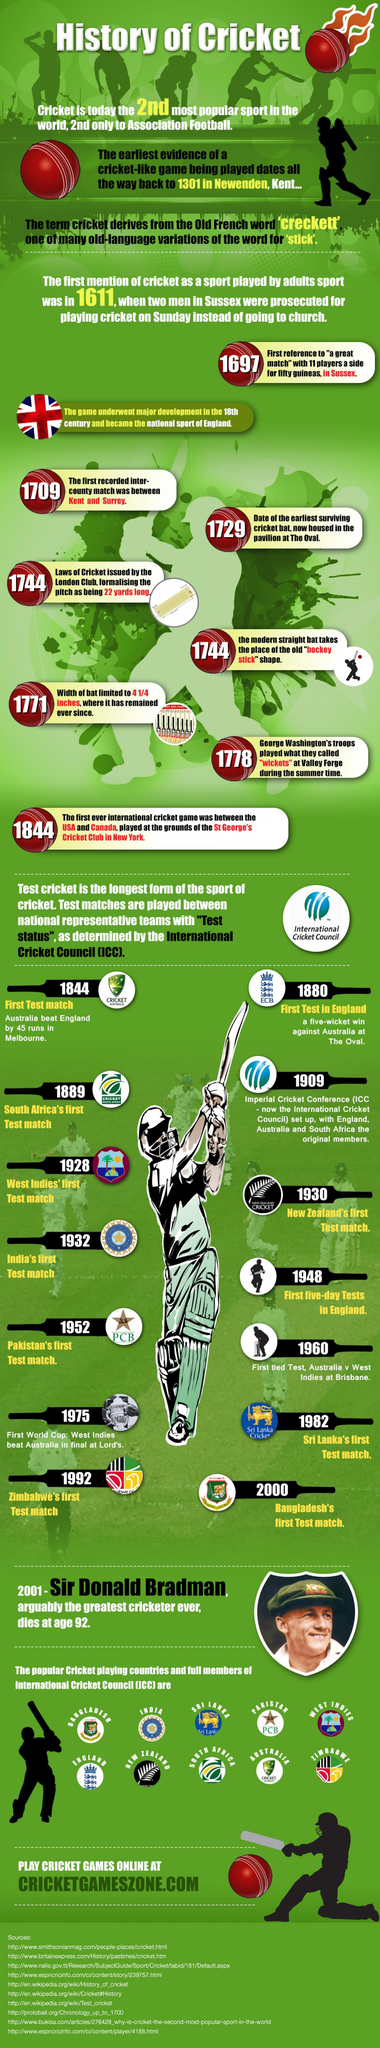Draw attention to some important aspects in this diagram. The country that played its first Test match last among the full members listed in the infographic is Bangladesh. The earliest teams in the International Cricket Council (ICC) were England, Australia, and South Africa, who were established in the late 19th and early 20th centuries. India played its first test match earlier than Sri Lanka or Pakistan. Out of the total number of full members of the ICC, only 10 have been shown the infographic. The first test match was played in Melbourne, where the history of cricket was written. 